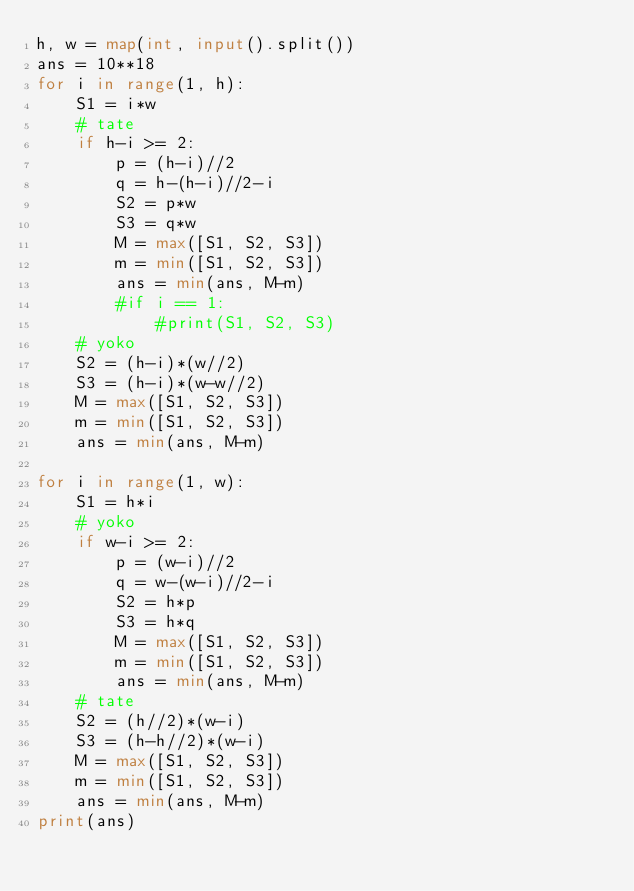<code> <loc_0><loc_0><loc_500><loc_500><_Python_>h, w = map(int, input().split())
ans = 10**18
for i in range(1, h):
    S1 = i*w
    # tate
    if h-i >= 2:
        p = (h-i)//2
        q = h-(h-i)//2-i
        S2 = p*w
        S3 = q*w
        M = max([S1, S2, S3])
        m = min([S1, S2, S3])
        ans = min(ans, M-m)
        #if i == 1:
            #print(S1, S2, S3)
    # yoko
    S2 = (h-i)*(w//2)
    S3 = (h-i)*(w-w//2)
    M = max([S1, S2, S3])
    m = min([S1, S2, S3])
    ans = min(ans, M-m)

for i in range(1, w):
    S1 = h*i
    # yoko
    if w-i >= 2:
        p = (w-i)//2
        q = w-(w-i)//2-i
        S2 = h*p
        S3 = h*q
        M = max([S1, S2, S3])
        m = min([S1, S2, S3])
        ans = min(ans, M-m)
    # tate
    S2 = (h//2)*(w-i)
    S3 = (h-h//2)*(w-i)
    M = max([S1, S2, S3])
    m = min([S1, S2, S3])
    ans = min(ans, M-m)
print(ans)
</code> 